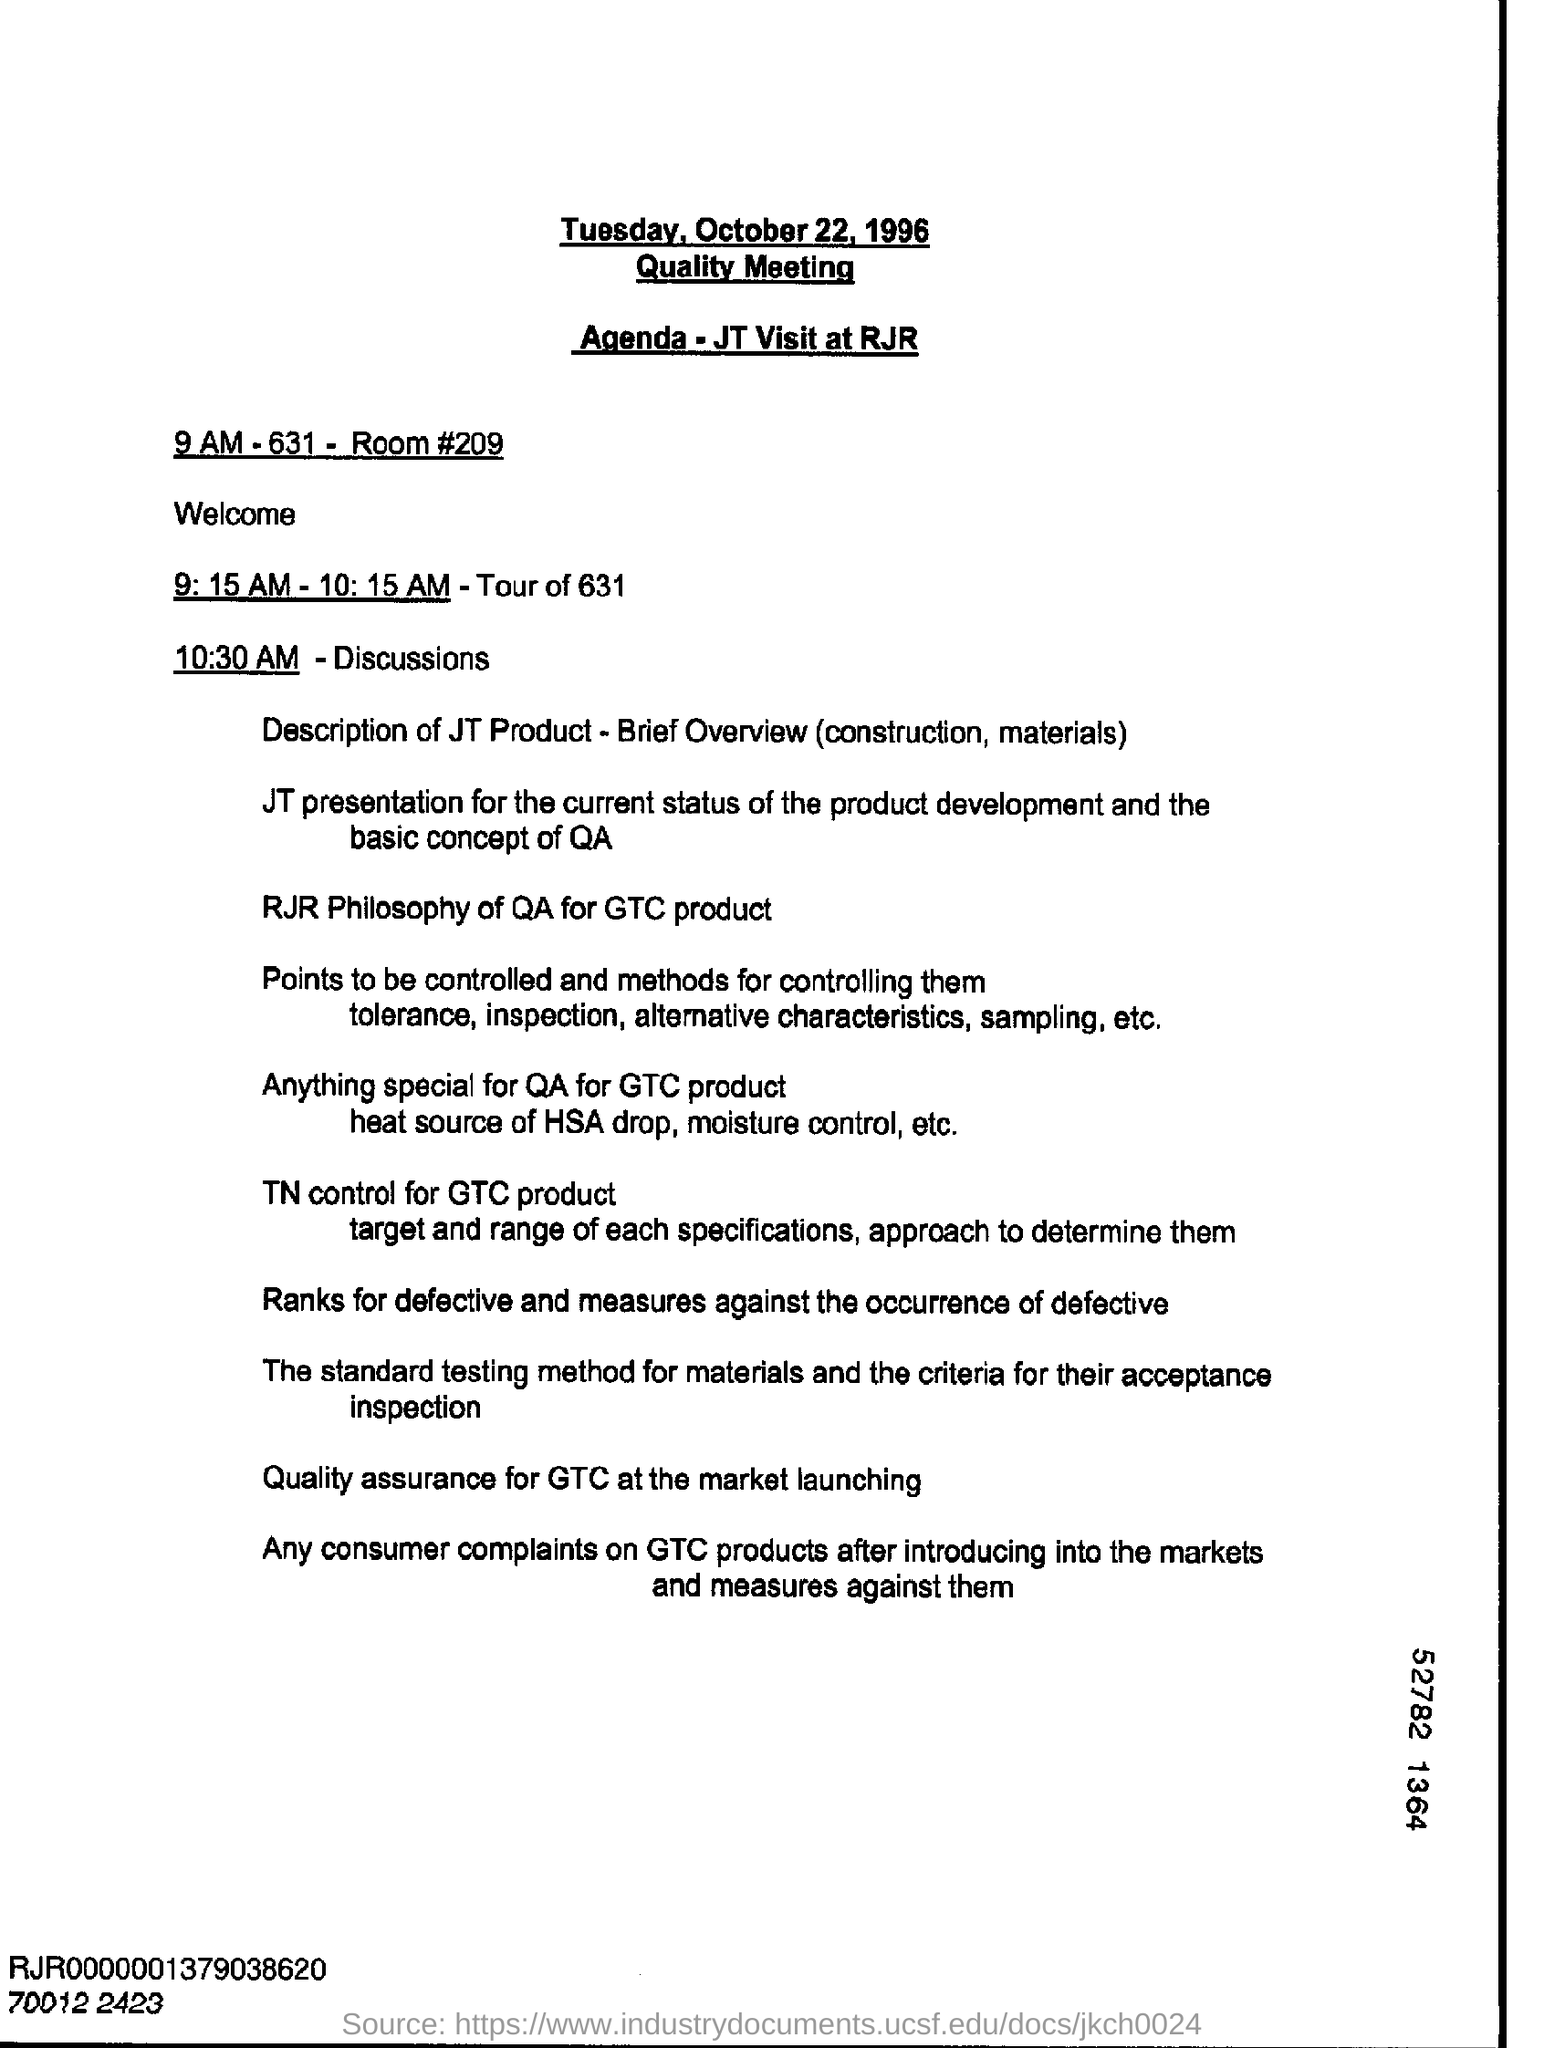On which date is the Quality Meeting scheduled?
Make the answer very short. Tuesday, October 22, 1996. What is the Room Number ?
Your response must be concise. 209. 